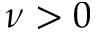<formula> <loc_0><loc_0><loc_500><loc_500>\nu > 0</formula> 